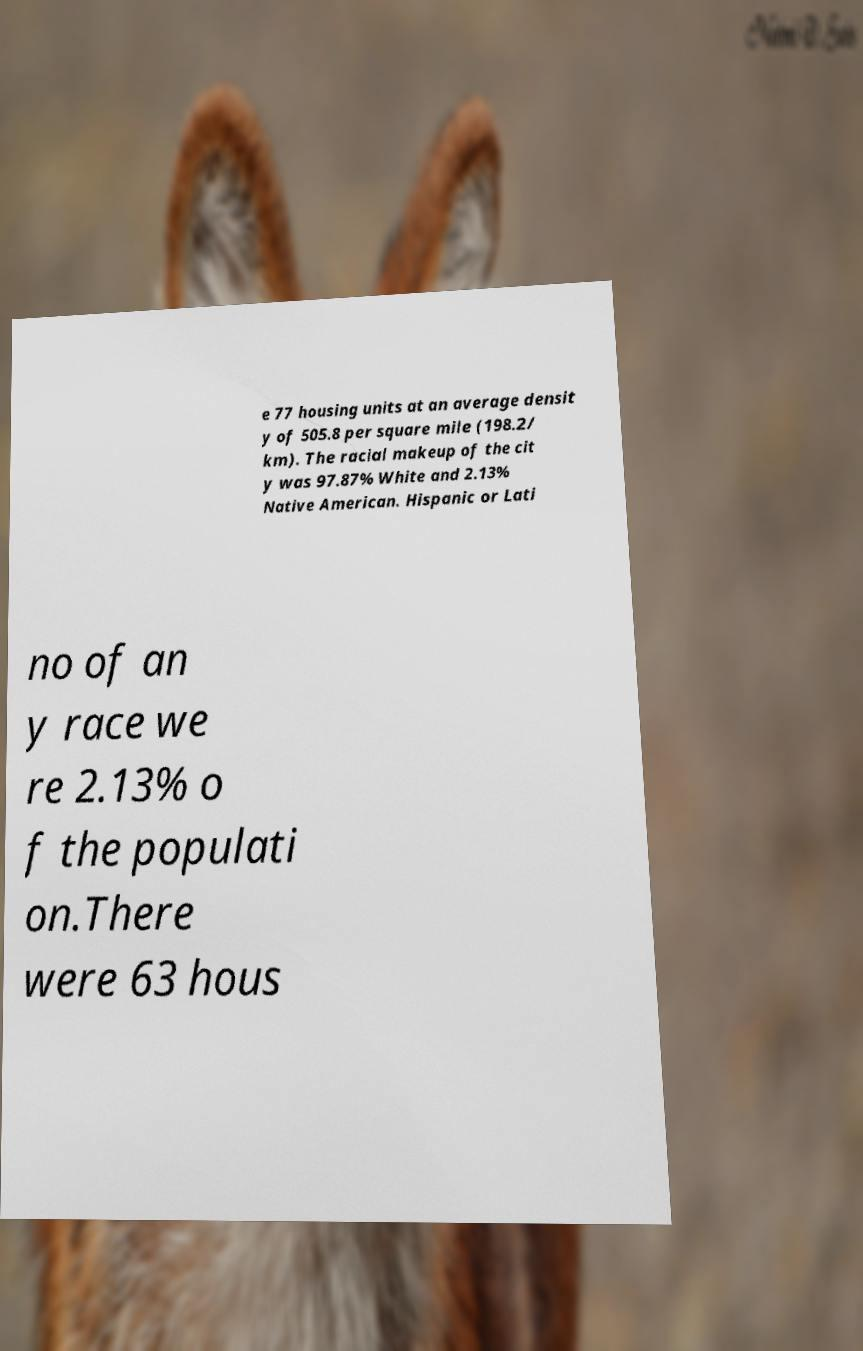What messages or text are displayed in this image? I need them in a readable, typed format. e 77 housing units at an average densit y of 505.8 per square mile (198.2/ km). The racial makeup of the cit y was 97.87% White and 2.13% Native American. Hispanic or Lati no of an y race we re 2.13% o f the populati on.There were 63 hous 